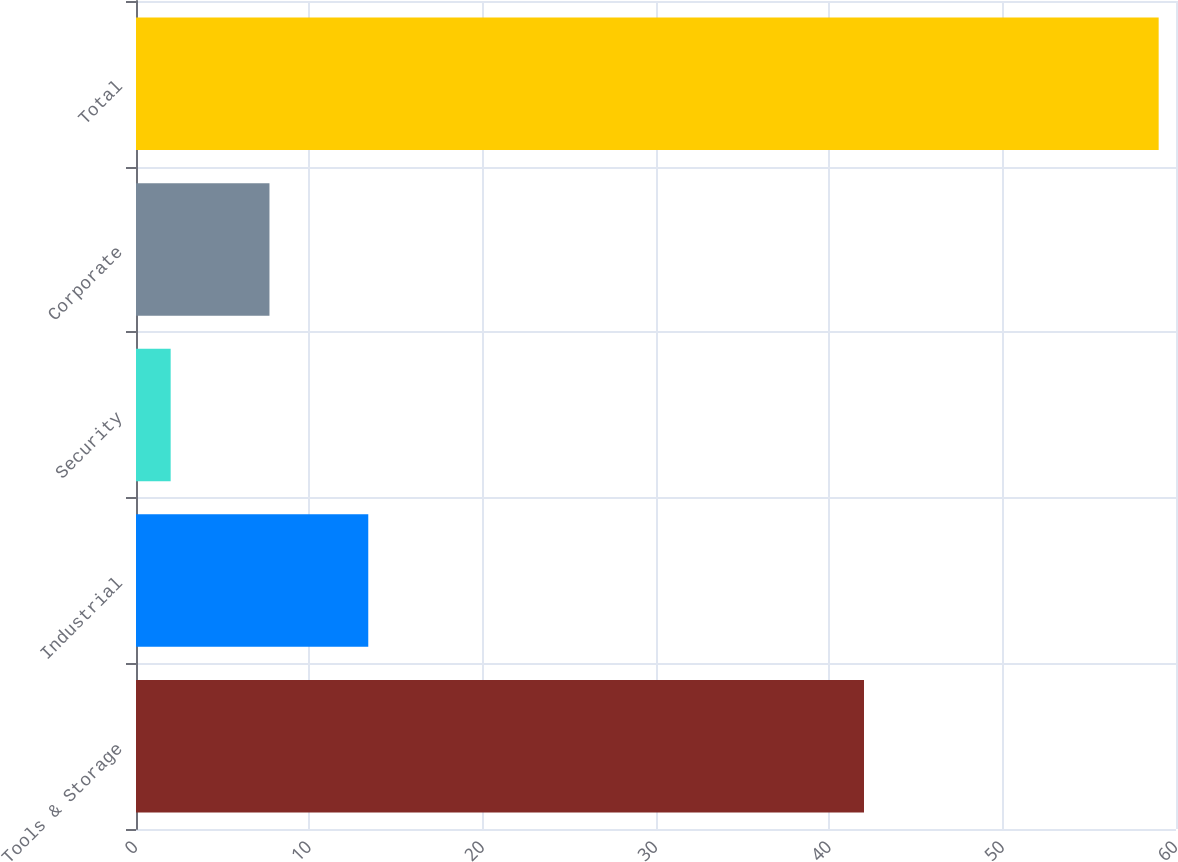<chart> <loc_0><loc_0><loc_500><loc_500><bar_chart><fcel>Tools & Storage<fcel>Industrial<fcel>Security<fcel>Corporate<fcel>Total<nl><fcel>42<fcel>13.4<fcel>2<fcel>7.7<fcel>59<nl></chart> 